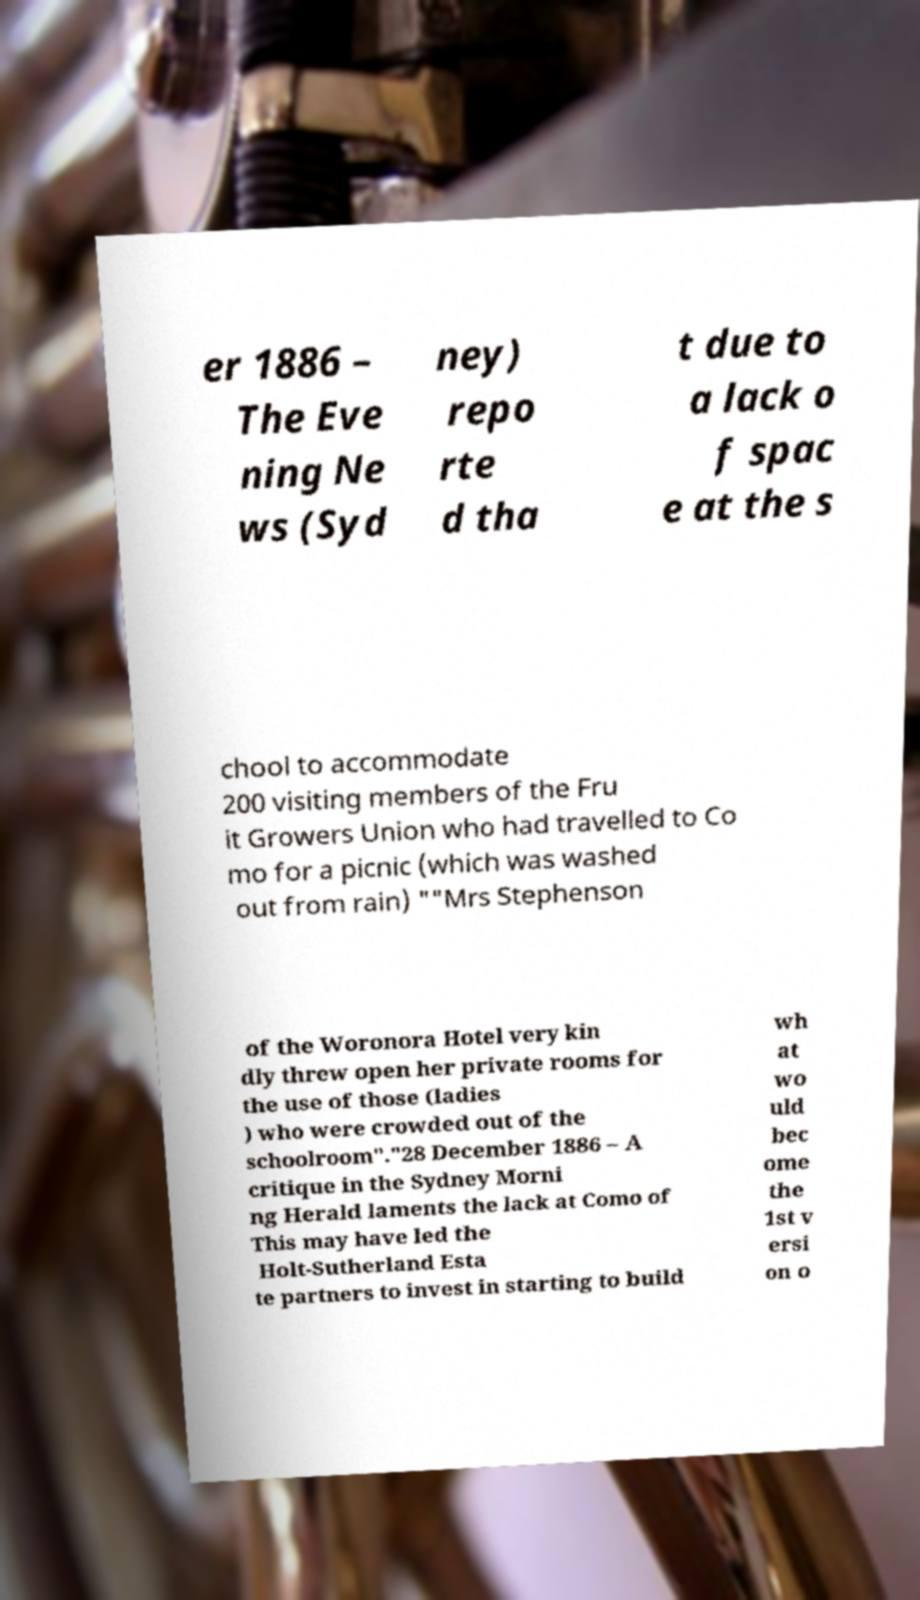What messages or text are displayed in this image? I need them in a readable, typed format. er 1886 – The Eve ning Ne ws (Syd ney) repo rte d tha t due to a lack o f spac e at the s chool to accommodate 200 visiting members of the Fru it Growers Union who had travelled to Co mo for a picnic (which was washed out from rain) ""Mrs Stephenson of the Woronora Hotel very kin dly threw open her private rooms for the use of those (ladies ) who were crowded out of the schoolroom"."28 December 1886 – A critique in the Sydney Morni ng Herald laments the lack at Como of This may have led the Holt-Sutherland Esta te partners to invest in starting to build wh at wo uld bec ome the 1st v ersi on o 